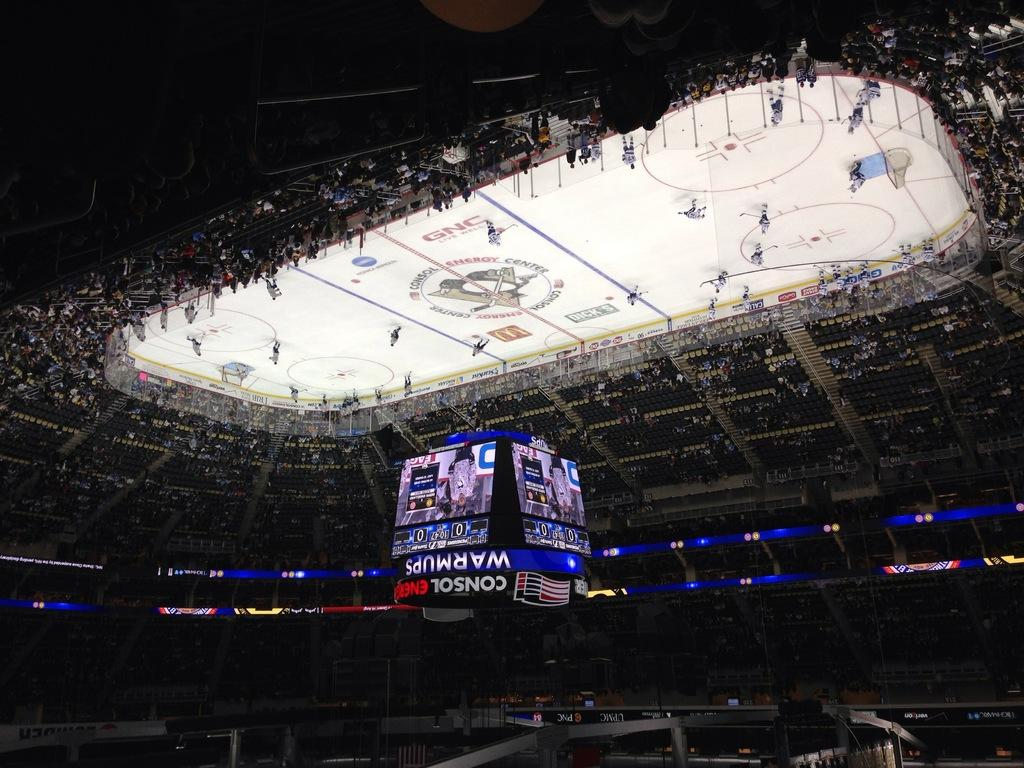<image>
Describe the image concisely. An upside down picture of an ice rink that is sponsored by GNC. 